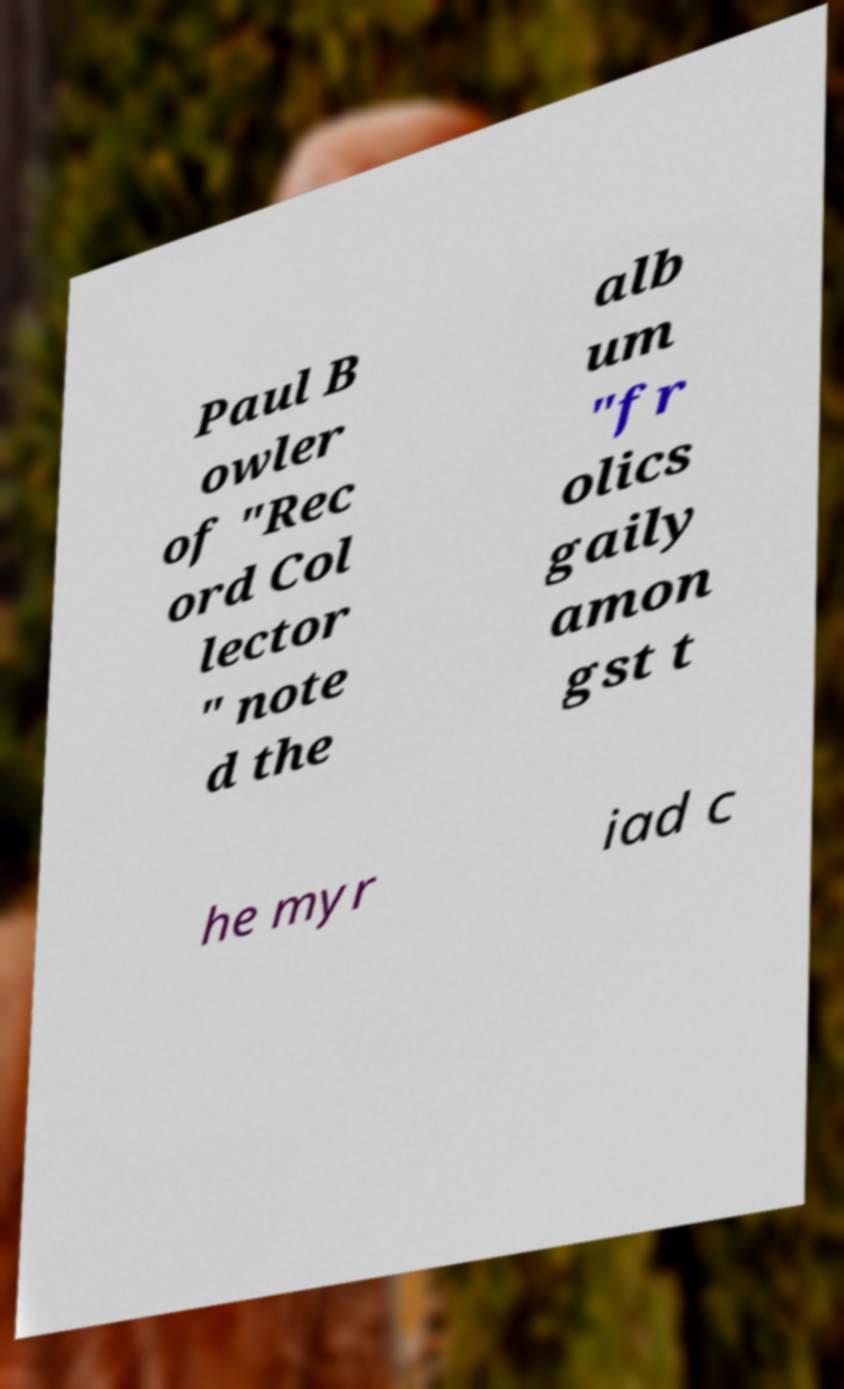What messages or text are displayed in this image? I need them in a readable, typed format. Paul B owler of "Rec ord Col lector " note d the alb um "fr olics gaily amon gst t he myr iad c 